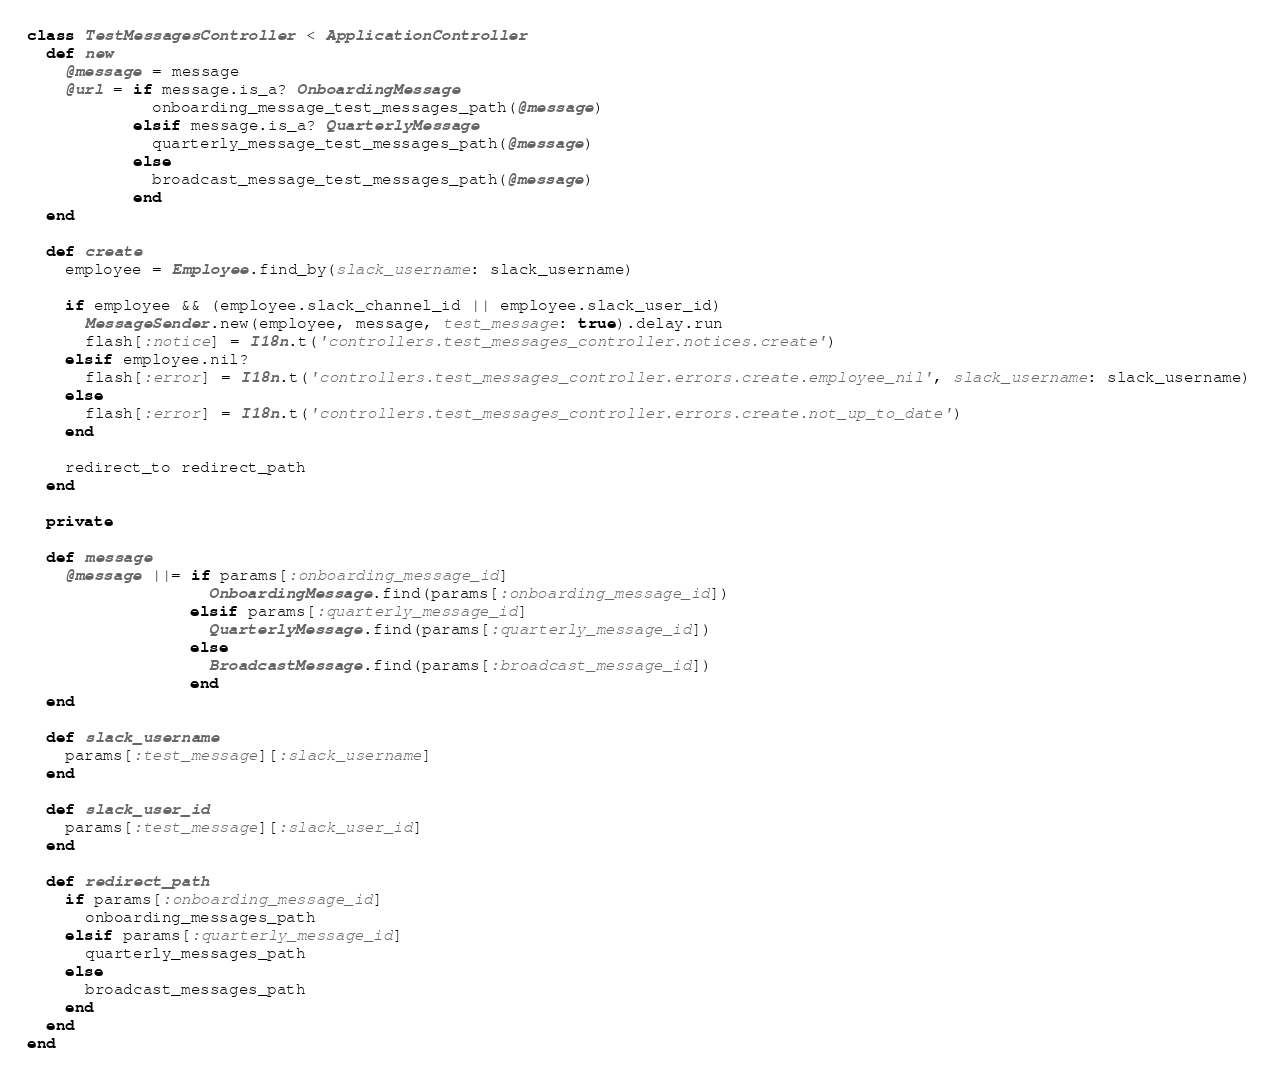<code> <loc_0><loc_0><loc_500><loc_500><_Ruby_>class TestMessagesController < ApplicationController
  def new
    @message = message
    @url = if message.is_a? OnboardingMessage
             onboarding_message_test_messages_path(@message)
           elsif message.is_a? QuarterlyMessage
             quarterly_message_test_messages_path(@message)
           else
             broadcast_message_test_messages_path(@message)
           end
  end

  def create
    employee = Employee.find_by(slack_username: slack_username)

    if employee && (employee.slack_channel_id || employee.slack_user_id)
      MessageSender.new(employee, message, test_message: true).delay.run
      flash[:notice] = I18n.t('controllers.test_messages_controller.notices.create')
    elsif employee.nil?
      flash[:error] = I18n.t('controllers.test_messages_controller.errors.create.employee_nil', slack_username: slack_username)
    else
      flash[:error] = I18n.t('controllers.test_messages_controller.errors.create.not_up_to_date')
    end

    redirect_to redirect_path
  end

  private

  def message
    @message ||= if params[:onboarding_message_id]
                   OnboardingMessage.find(params[:onboarding_message_id])
                 elsif params[:quarterly_message_id]
                   QuarterlyMessage.find(params[:quarterly_message_id])
                 else
                   BroadcastMessage.find(params[:broadcast_message_id])
                 end
  end

  def slack_username
    params[:test_message][:slack_username]
  end

  def slack_user_id
    params[:test_message][:slack_user_id]
  end

  def redirect_path
    if params[:onboarding_message_id]
      onboarding_messages_path
    elsif params[:quarterly_message_id]
      quarterly_messages_path
    else
      broadcast_messages_path
    end
  end
end
</code> 